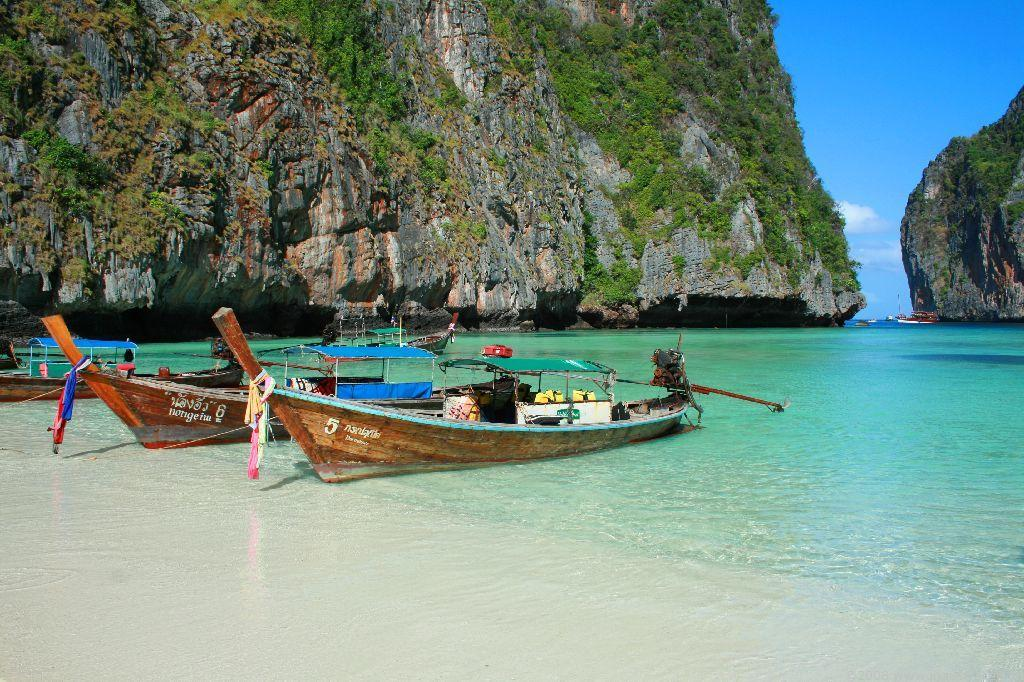<image>
Provide a brief description of the given image. Boats that are numbered with 5 and 6 are lined up on a beach. 